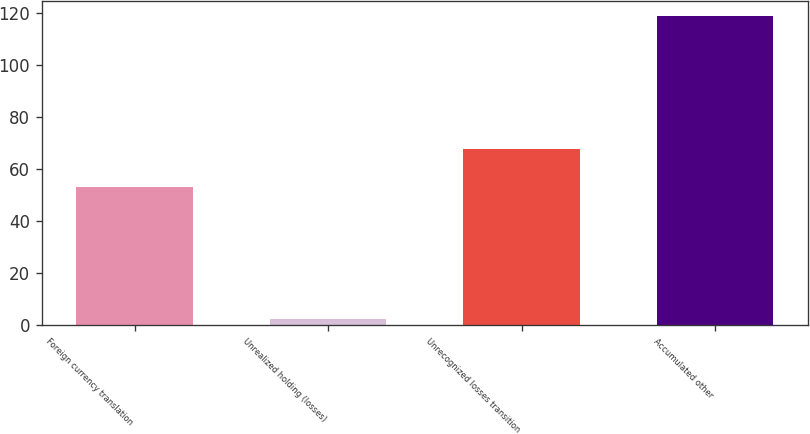<chart> <loc_0><loc_0><loc_500><loc_500><bar_chart><fcel>Foreign currency translation<fcel>Unrealized holding (losses)<fcel>Unrecognized losses transition<fcel>Accumulated other<nl><fcel>53<fcel>2.2<fcel>67.8<fcel>118.6<nl></chart> 